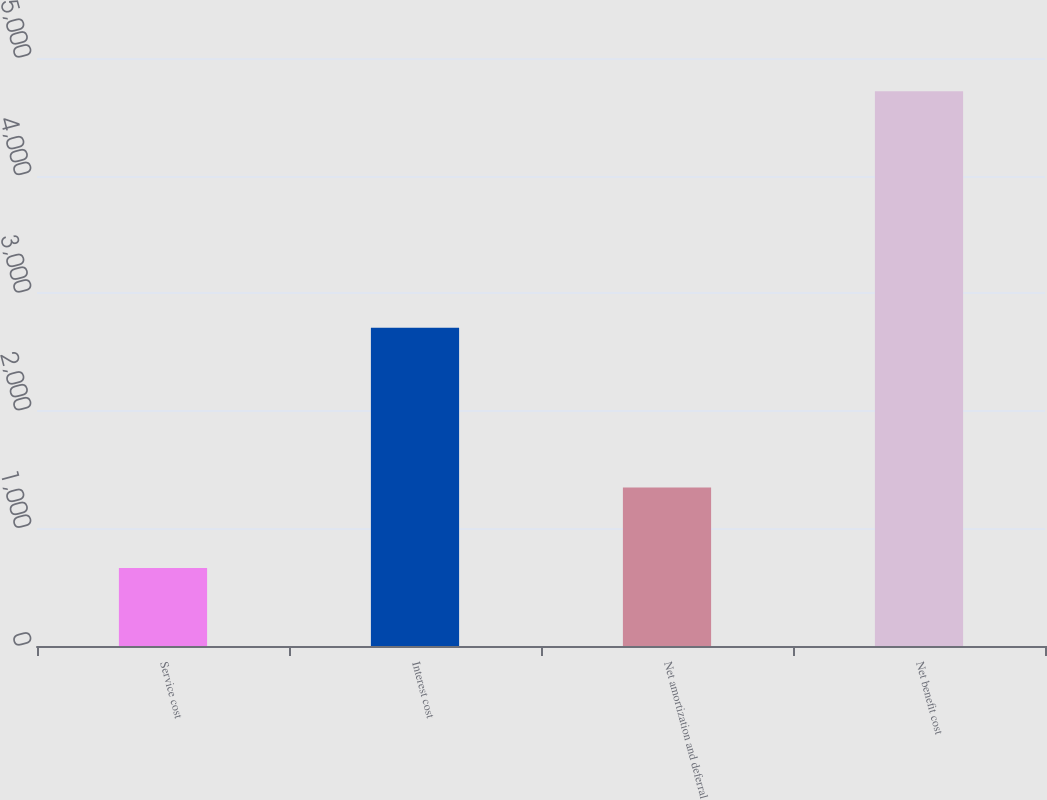Convert chart. <chart><loc_0><loc_0><loc_500><loc_500><bar_chart><fcel>Service cost<fcel>Interest cost<fcel>Net amortization and deferral<fcel>Net benefit cost<nl><fcel>663<fcel>2707<fcel>1348<fcel>4718<nl></chart> 